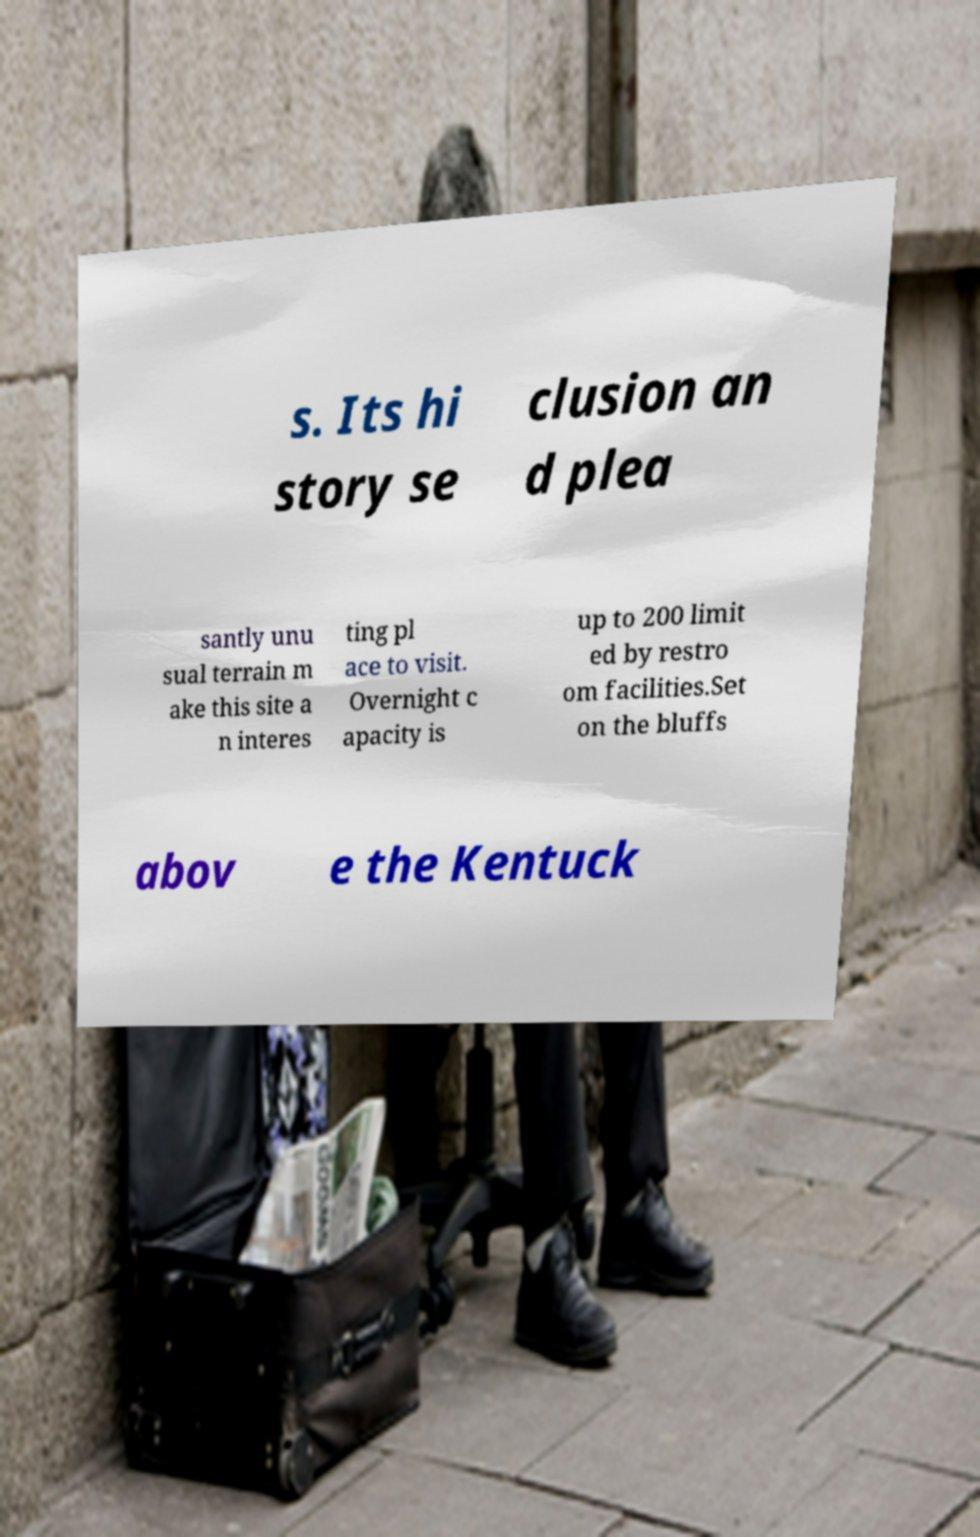There's text embedded in this image that I need extracted. Can you transcribe it verbatim? s. Its hi story se clusion an d plea santly unu sual terrain m ake this site a n interes ting pl ace to visit. Overnight c apacity is up to 200 limit ed by restro om facilities.Set on the bluffs abov e the Kentuck 